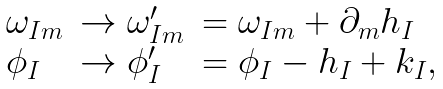<formula> <loc_0><loc_0><loc_500><loc_500>\begin{array} { l l l } { { \omega _ { I m } } } & { { \rightarrow \omega _ { I m } ^ { \prime } } } & { { = \omega _ { I m } + \partial _ { m } h _ { I } } } \\ { { \phi _ { I } } } & { { \rightarrow \phi _ { I } ^ { \prime } } } & { { = \phi _ { I } - h _ { I } + k _ { I } , } } \end{array}</formula> 